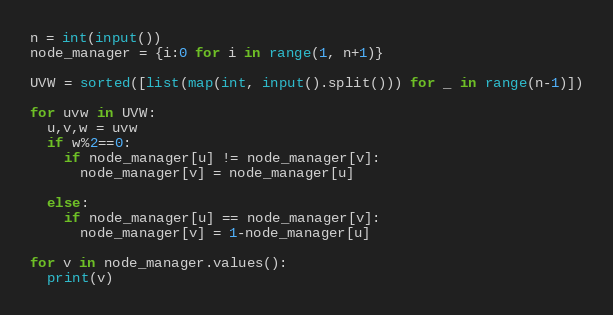<code> <loc_0><loc_0><loc_500><loc_500><_Python_>n = int(input())
node_manager = {i:0 for i in range(1, n+1)}

UVW = sorted([list(map(int, input().split())) for _ in range(n-1)])

for uvw in UVW:
  u,v,w = uvw
  if w%2==0:
    if node_manager[u] != node_manager[v]:
      node_manager[v] = node_manager[u]
    
  else:
    if node_manager[u] == node_manager[v]:
      node_manager[v] = 1-node_manager[u]
      
for v in node_manager.values():
  print(v)</code> 